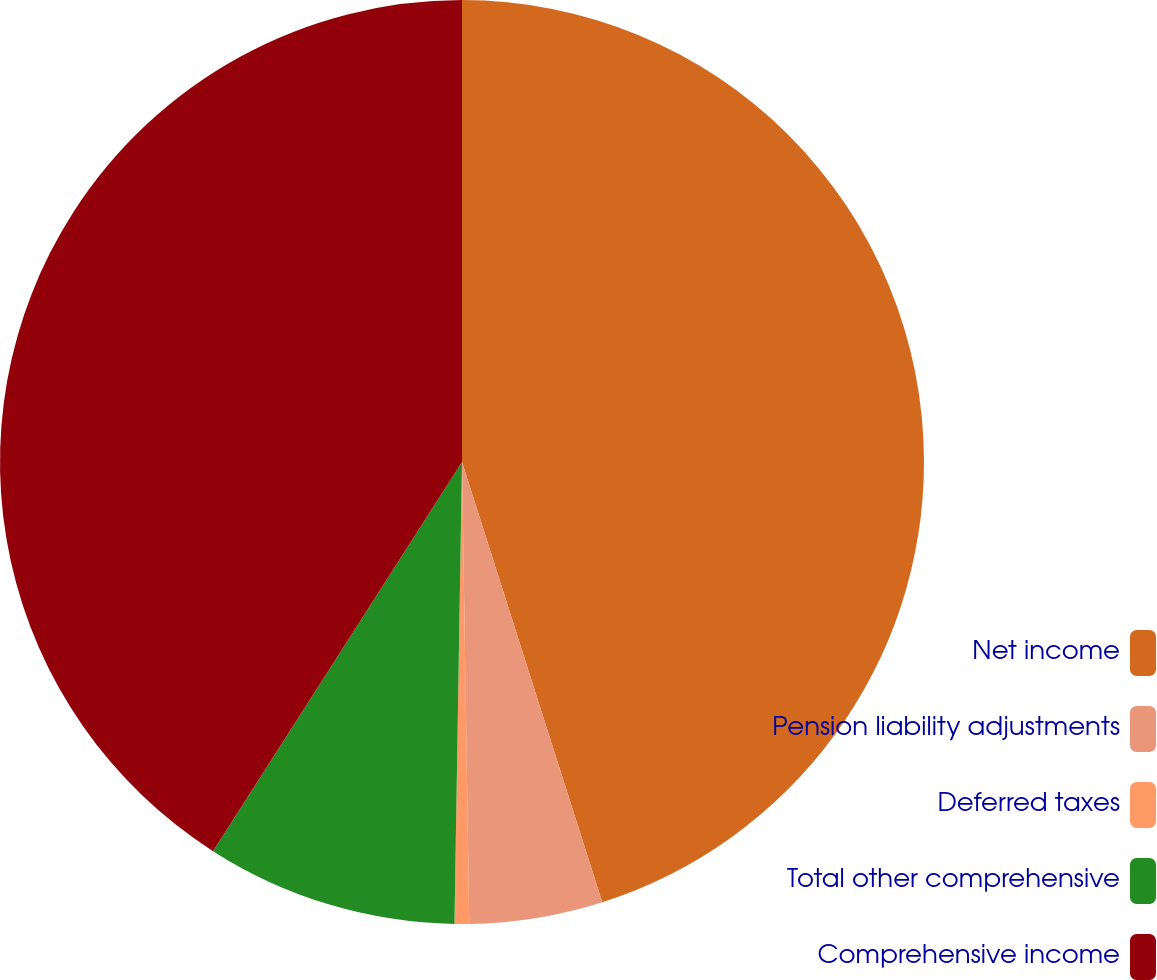<chart> <loc_0><loc_0><loc_500><loc_500><pie_chart><fcel>Net income<fcel>Pension liability adjustments<fcel>Deferred taxes<fcel>Total other comprehensive<fcel>Comprehensive income<nl><fcel>45.09%<fcel>4.66%<fcel>0.51%<fcel>8.8%<fcel>40.94%<nl></chart> 